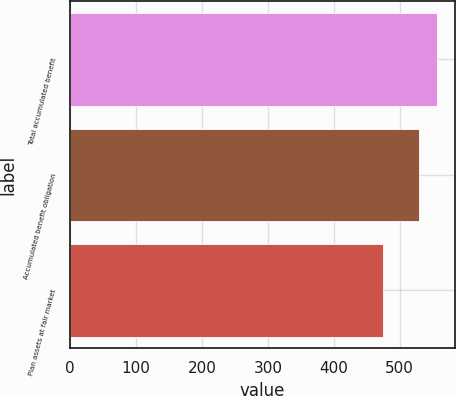<chart> <loc_0><loc_0><loc_500><loc_500><bar_chart><fcel>Total accumulated benefit<fcel>Accumulated benefit obligation<fcel>Plan assets at fair market<nl><fcel>556.4<fcel>530.1<fcel>475.3<nl></chart> 